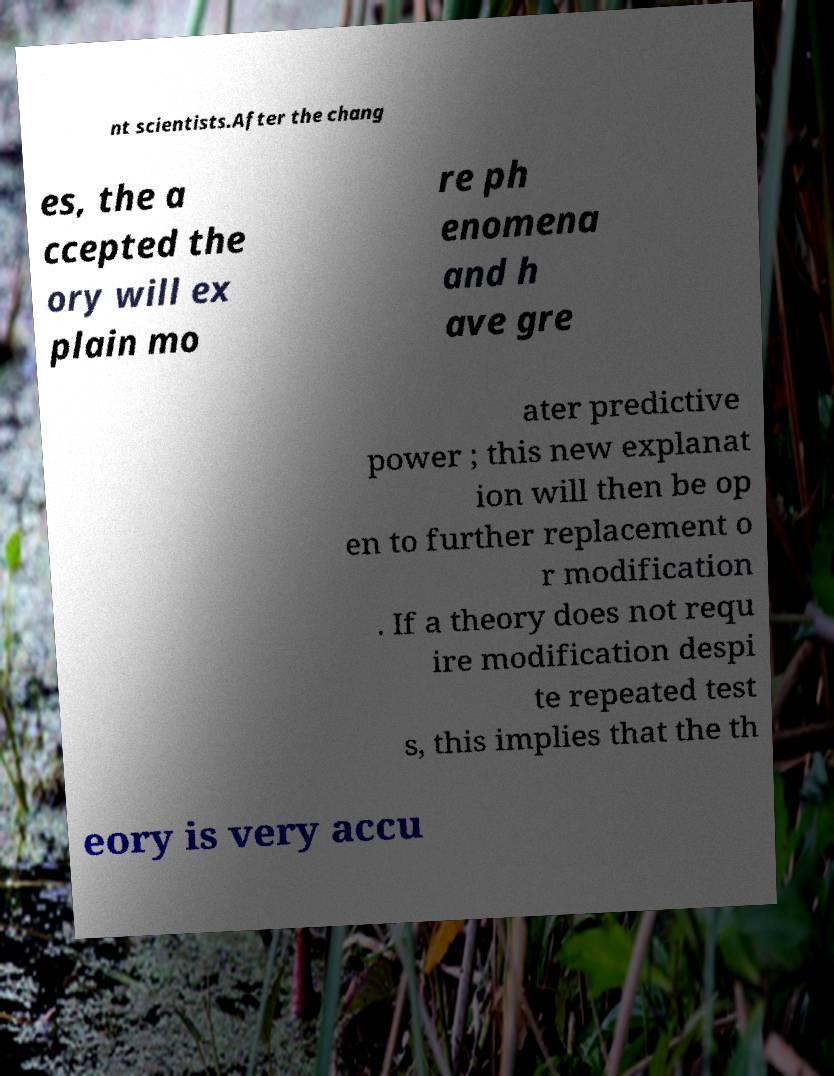I need the written content from this picture converted into text. Can you do that? nt scientists.After the chang es, the a ccepted the ory will ex plain mo re ph enomena and h ave gre ater predictive power ; this new explanat ion will then be op en to further replacement o r modification . If a theory does not requ ire modification despi te repeated test s, this implies that the th eory is very accu 